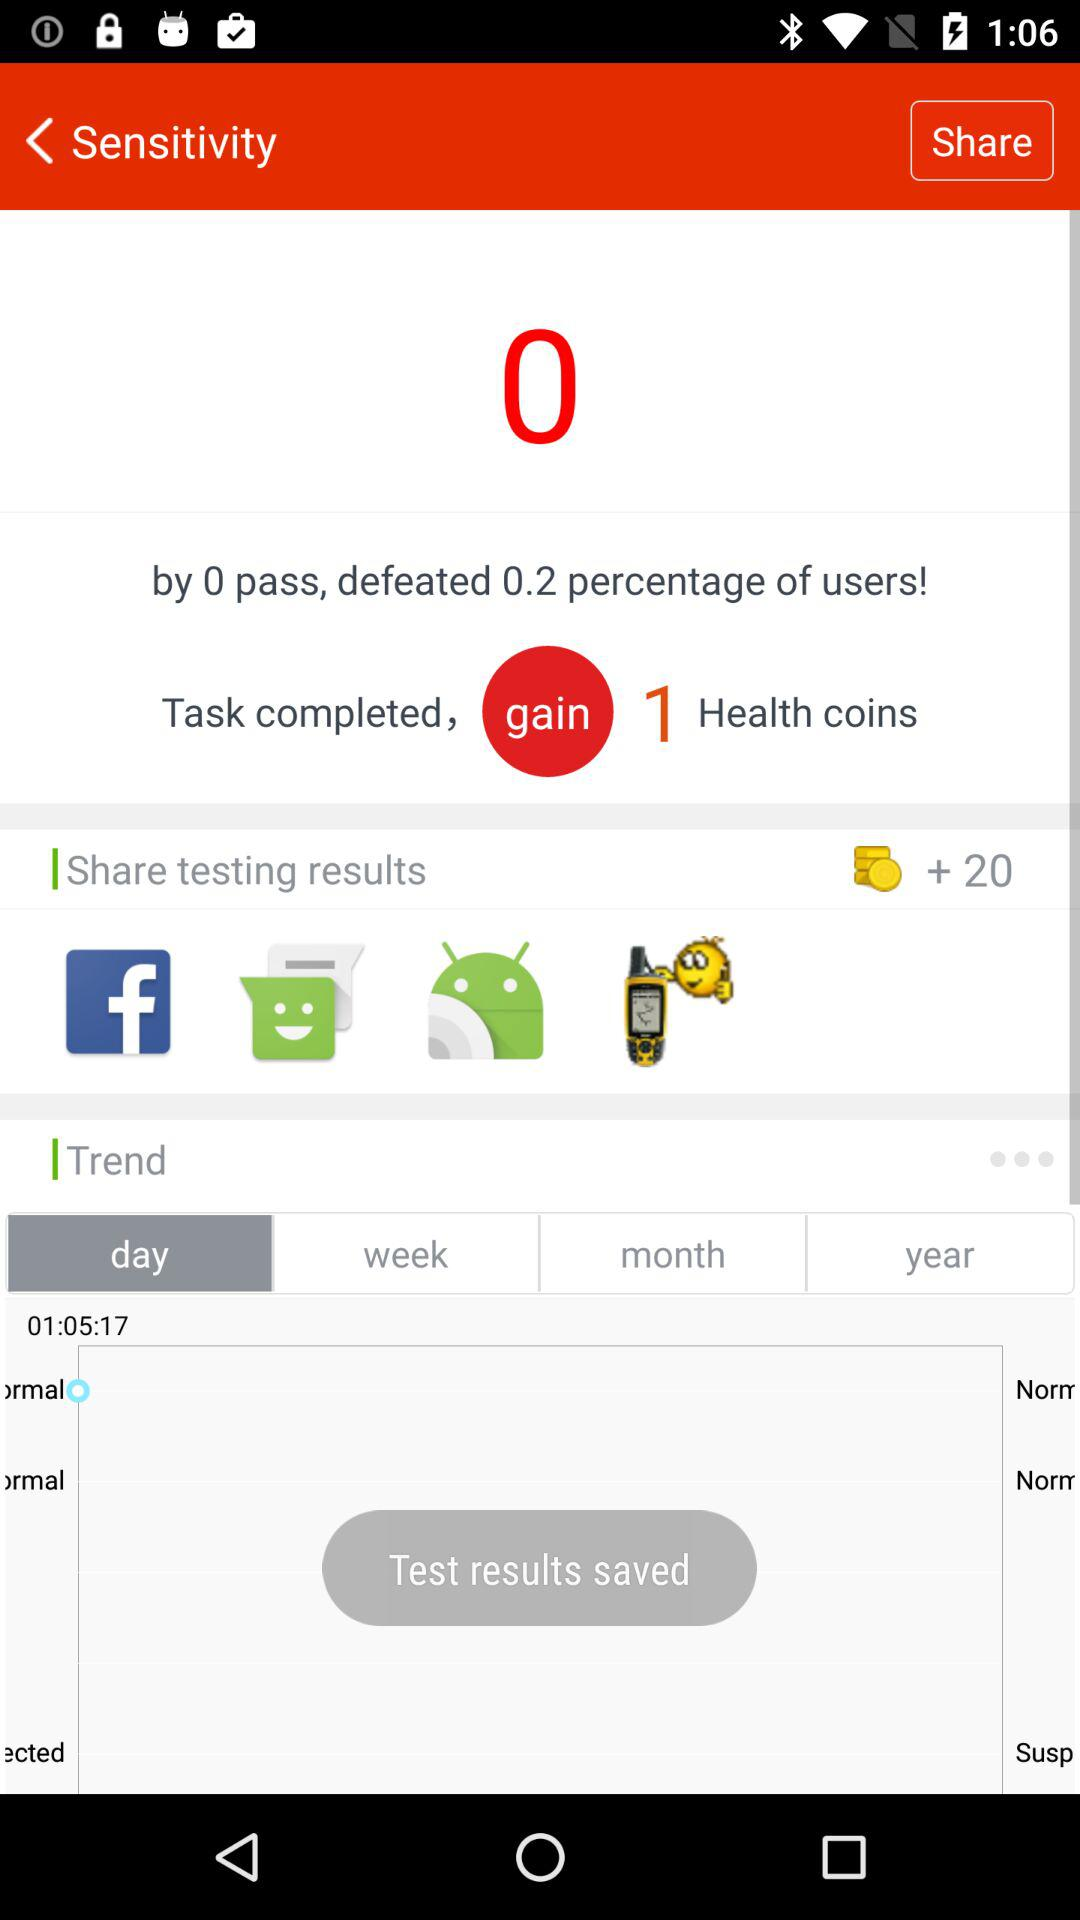Through which application can we share the testing results? You can share the testing results through "Facebook", "Messaging", "Android Beam" and "Fake GPS - Search location". 